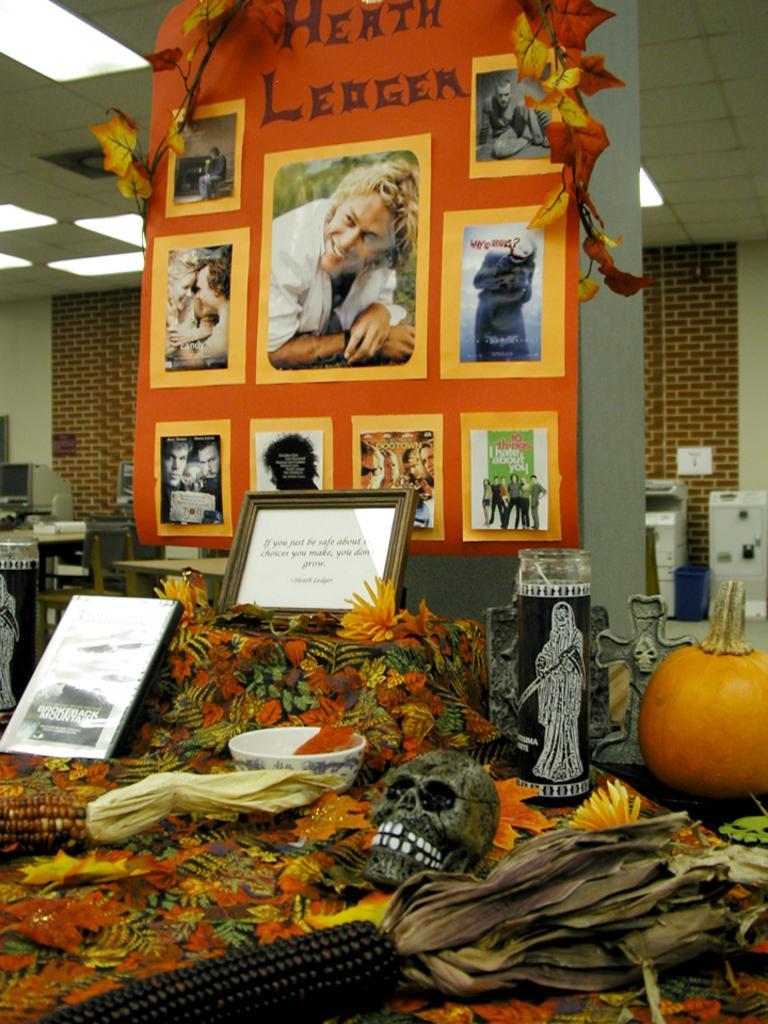Can you describe this image briefly? In this image we can see a poster with some images and text, there are some objects like, photo frame, bowl, sculpture, skull, pumpkin, flowers and other, at the top of the roof we can see some lights. 